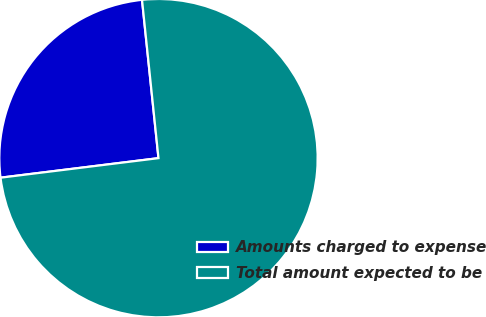Convert chart. <chart><loc_0><loc_0><loc_500><loc_500><pie_chart><fcel>Amounts charged to expense<fcel>Total amount expected to be<nl><fcel>25.31%<fcel>74.69%<nl></chart> 